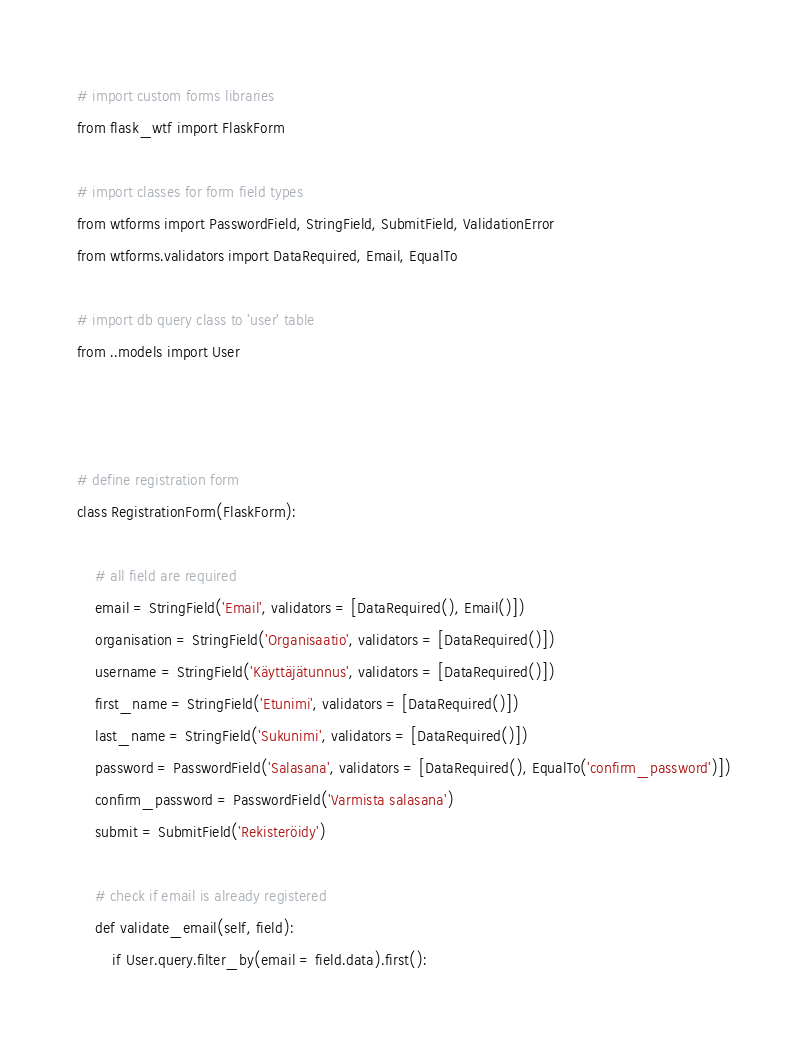Convert code to text. <code><loc_0><loc_0><loc_500><loc_500><_Python_># import custom forms libraries
from flask_wtf import FlaskForm

# import classes for form field types
from wtforms import PasswordField, StringField, SubmitField, ValidationError
from wtforms.validators import DataRequired, Email, EqualTo

# import db query class to 'user' table
from ..models import User



# define registration form
class RegistrationForm(FlaskForm):

    # all field are required
    email = StringField('Email', validators = [DataRequired(), Email()])
    organisation = StringField('Organisaatio', validators = [DataRequired()])
    username = StringField('Käyttäjätunnus', validators = [DataRequired()])
    first_name = StringField('Etunimi', validators = [DataRequired()])
    last_name = StringField('Sukunimi', validators = [DataRequired()])
    password = PasswordField('Salasana', validators = [DataRequired(), EqualTo('confirm_password')])
    confirm_password = PasswordField('Varmista salasana')
    submit = SubmitField('Rekisteröidy')

	# check if email is already registered
    def validate_email(self, field):
        if User.query.filter_by(email = field.data).first():</code> 